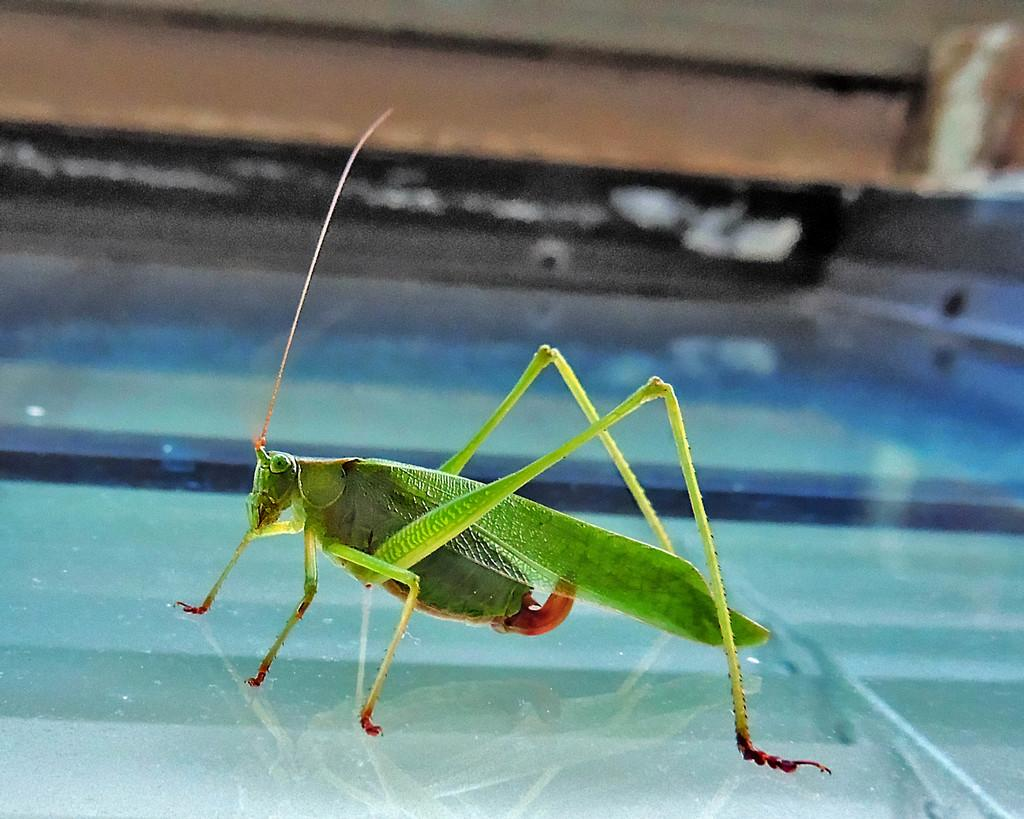What insect is present on the glass surface in the image? There is a locust on a glass surface in the image. What is the position of the earth in relation to the locust in the image? The image does not show the earth or its position in relation to the locust. --- Facts: 1. There is a person holding a book in the image. 2. The person is sitting on a chair. 3. The chair is made of wood. 4. The book has a blue cover. Absurd Topics: ocean, dance, rainbow Conversation: What is the person in the image holding? The person in the image is holding a book. What is the person's posture in the image? The person is sitting on a chair. What material is the chair made of? The chair is made of wood. What color is the book's cover? The book has a blue cover. Reasoning: Let's think step by step in order to produce the conversation. We start by identifying the main subject in the image, which is the person holding a book. Then, we describe the person's posture and the material of the chair. Finally, we mention the color of the book's cover. Each question is designed to elicit a specific detail about the image that is known from the provided facts. Absurd Question/Answer: Can you see a rainbow in the image? There is no rainbow present in the image. 